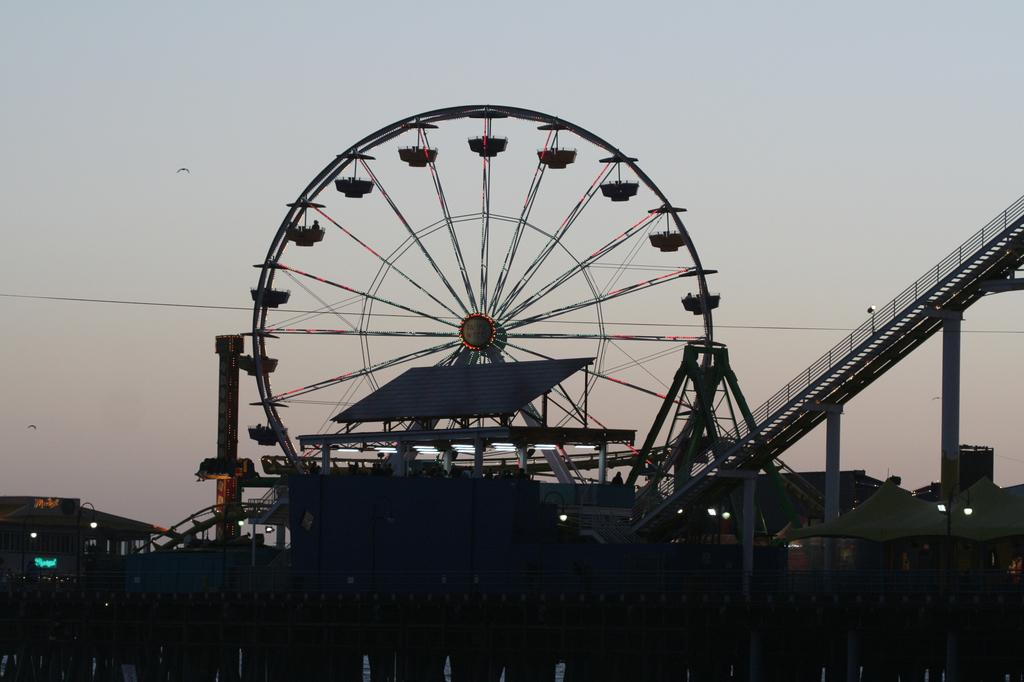What is the main structure in the center of the image? There is a giant wheel in the center of the image. What can be seen on the right side of the image? There is a bridge on the right side of the image. What type of man-made structures are present in the image? There are buildings in the image. What can be seen illuminating the image? There are lights in the image. What is visible in the background of the image? The sky is visible in the image. How many times does the room burst in the image? There is no room present in the image, so it cannot burst. 